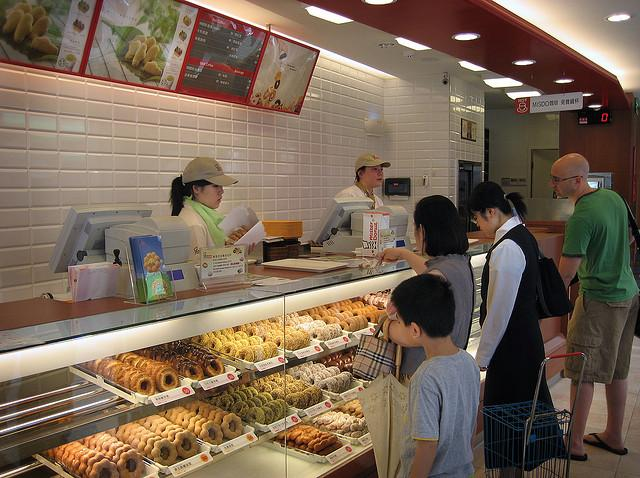In which liquid were most of the shown treats boiled? Please explain your reasoning. oil. A display case is filled with donuts. 